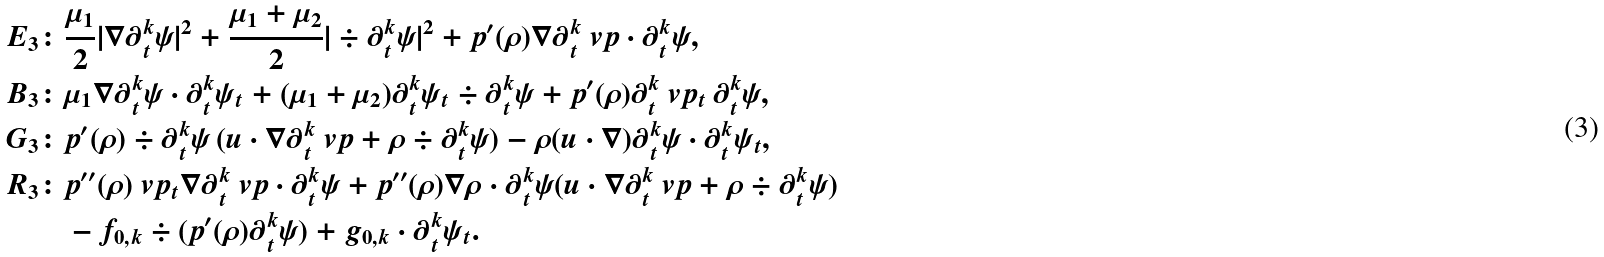Convert formula to latex. <formula><loc_0><loc_0><loc_500><loc_500>E _ { 3 } \colon & \frac { \mu _ { 1 } } { 2 } | \nabla \partial _ { t } ^ { k } \psi | ^ { 2 } + \frac { \mu _ { 1 } + \mu _ { 2 } } { 2 } | \div \partial _ { t } ^ { k } \psi | ^ { 2 } + p ^ { \prime } ( \rho ) \nabla \partial _ { t } ^ { k } \ v p \cdot \partial _ { t } ^ { k } \psi , \\ B _ { 3 } \colon & \mu _ { 1 } \nabla \partial _ { t } ^ { k } \psi \cdot \partial _ { t } ^ { k } \psi _ { t } + ( \mu _ { 1 } + \mu _ { 2 } ) \partial _ { t } ^ { k } \psi _ { t } \div \partial _ { t } ^ { k } \psi + p ^ { \prime } ( \rho ) \partial _ { t } ^ { k } \ v p _ { t } \, \partial _ { t } ^ { k } \psi , \\ G _ { 3 } \colon & p ^ { \prime } ( \rho ) \div \partial _ { t } ^ { k } \psi \, ( u \cdot \nabla \partial _ { t } ^ { k } \ v p + \rho \div \partial _ { t } ^ { k } \psi ) - \rho ( u \cdot \nabla ) \partial _ { t } ^ { k } \psi \cdot \partial _ { t } ^ { k } \psi _ { t } , \\ R _ { 3 } \colon & p ^ { \prime \prime } ( \rho ) \ v p _ { t } \nabla \partial _ { t } ^ { k } \ v p \cdot \partial _ { t } ^ { k } \psi + p ^ { \prime \prime } ( \rho ) \nabla \rho \cdot \partial _ { t } ^ { k } \psi ( u \cdot \nabla \partial _ { t } ^ { k } \ v p + \rho \div \partial _ { t } ^ { k } \psi ) \\ & - f _ { 0 , k } \div ( p ^ { \prime } ( \rho ) \partial _ { t } ^ { k } \psi ) + g _ { 0 , k } \cdot \partial _ { t } ^ { k } \psi _ { t } .</formula> 